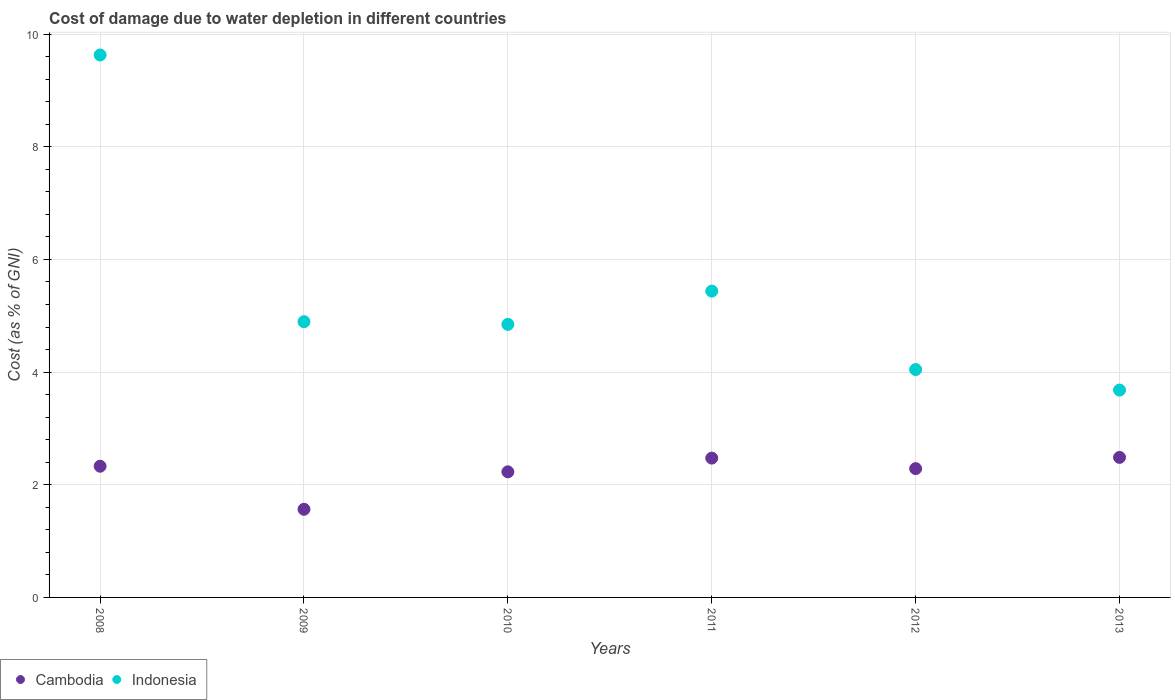What is the cost of damage caused due to water depletion in Indonesia in 2008?
Make the answer very short. 9.63. Across all years, what is the maximum cost of damage caused due to water depletion in Cambodia?
Offer a very short reply. 2.49. Across all years, what is the minimum cost of damage caused due to water depletion in Indonesia?
Provide a succinct answer. 3.68. In which year was the cost of damage caused due to water depletion in Indonesia minimum?
Provide a short and direct response. 2013. What is the total cost of damage caused due to water depletion in Cambodia in the graph?
Provide a succinct answer. 13.37. What is the difference between the cost of damage caused due to water depletion in Cambodia in 2011 and that in 2013?
Provide a short and direct response. -0.01. What is the difference between the cost of damage caused due to water depletion in Indonesia in 2010 and the cost of damage caused due to water depletion in Cambodia in 2009?
Keep it short and to the point. 3.28. What is the average cost of damage caused due to water depletion in Cambodia per year?
Your response must be concise. 2.23. In the year 2008, what is the difference between the cost of damage caused due to water depletion in Cambodia and cost of damage caused due to water depletion in Indonesia?
Your response must be concise. -7.3. What is the ratio of the cost of damage caused due to water depletion in Cambodia in 2010 to that in 2012?
Ensure brevity in your answer.  0.98. What is the difference between the highest and the second highest cost of damage caused due to water depletion in Cambodia?
Provide a succinct answer. 0.01. What is the difference between the highest and the lowest cost of damage caused due to water depletion in Cambodia?
Provide a short and direct response. 0.92. Is the sum of the cost of damage caused due to water depletion in Cambodia in 2008 and 2009 greater than the maximum cost of damage caused due to water depletion in Indonesia across all years?
Your answer should be compact. No. Is the cost of damage caused due to water depletion in Indonesia strictly greater than the cost of damage caused due to water depletion in Cambodia over the years?
Give a very brief answer. Yes. Is the cost of damage caused due to water depletion in Cambodia strictly less than the cost of damage caused due to water depletion in Indonesia over the years?
Make the answer very short. Yes. What is the difference between two consecutive major ticks on the Y-axis?
Make the answer very short. 2. Does the graph contain any zero values?
Ensure brevity in your answer.  No. How many legend labels are there?
Provide a short and direct response. 2. What is the title of the graph?
Make the answer very short. Cost of damage due to water depletion in different countries. What is the label or title of the X-axis?
Offer a terse response. Years. What is the label or title of the Y-axis?
Your answer should be very brief. Cost (as % of GNI). What is the Cost (as % of GNI) in Cambodia in 2008?
Provide a succinct answer. 2.33. What is the Cost (as % of GNI) of Indonesia in 2008?
Keep it short and to the point. 9.63. What is the Cost (as % of GNI) in Cambodia in 2009?
Provide a short and direct response. 1.56. What is the Cost (as % of GNI) in Indonesia in 2009?
Keep it short and to the point. 4.9. What is the Cost (as % of GNI) in Cambodia in 2010?
Your answer should be compact. 2.23. What is the Cost (as % of GNI) of Indonesia in 2010?
Your answer should be very brief. 4.85. What is the Cost (as % of GNI) of Cambodia in 2011?
Ensure brevity in your answer.  2.47. What is the Cost (as % of GNI) in Indonesia in 2011?
Keep it short and to the point. 5.44. What is the Cost (as % of GNI) of Cambodia in 2012?
Provide a short and direct response. 2.29. What is the Cost (as % of GNI) in Indonesia in 2012?
Make the answer very short. 4.05. What is the Cost (as % of GNI) in Cambodia in 2013?
Your answer should be compact. 2.49. What is the Cost (as % of GNI) in Indonesia in 2013?
Provide a short and direct response. 3.68. Across all years, what is the maximum Cost (as % of GNI) in Cambodia?
Your answer should be compact. 2.49. Across all years, what is the maximum Cost (as % of GNI) in Indonesia?
Offer a very short reply. 9.63. Across all years, what is the minimum Cost (as % of GNI) in Cambodia?
Keep it short and to the point. 1.56. Across all years, what is the minimum Cost (as % of GNI) of Indonesia?
Make the answer very short. 3.68. What is the total Cost (as % of GNI) in Cambodia in the graph?
Provide a succinct answer. 13.37. What is the total Cost (as % of GNI) in Indonesia in the graph?
Keep it short and to the point. 32.54. What is the difference between the Cost (as % of GNI) in Cambodia in 2008 and that in 2009?
Provide a succinct answer. 0.76. What is the difference between the Cost (as % of GNI) of Indonesia in 2008 and that in 2009?
Make the answer very short. 4.73. What is the difference between the Cost (as % of GNI) in Cambodia in 2008 and that in 2010?
Your answer should be compact. 0.1. What is the difference between the Cost (as % of GNI) of Indonesia in 2008 and that in 2010?
Provide a short and direct response. 4.78. What is the difference between the Cost (as % of GNI) of Cambodia in 2008 and that in 2011?
Keep it short and to the point. -0.14. What is the difference between the Cost (as % of GNI) of Indonesia in 2008 and that in 2011?
Ensure brevity in your answer.  4.19. What is the difference between the Cost (as % of GNI) of Cambodia in 2008 and that in 2012?
Ensure brevity in your answer.  0.04. What is the difference between the Cost (as % of GNI) in Indonesia in 2008 and that in 2012?
Provide a short and direct response. 5.58. What is the difference between the Cost (as % of GNI) of Cambodia in 2008 and that in 2013?
Offer a terse response. -0.16. What is the difference between the Cost (as % of GNI) in Indonesia in 2008 and that in 2013?
Make the answer very short. 5.95. What is the difference between the Cost (as % of GNI) in Cambodia in 2009 and that in 2010?
Give a very brief answer. -0.66. What is the difference between the Cost (as % of GNI) of Indonesia in 2009 and that in 2010?
Make the answer very short. 0.05. What is the difference between the Cost (as % of GNI) of Cambodia in 2009 and that in 2011?
Your answer should be very brief. -0.91. What is the difference between the Cost (as % of GNI) of Indonesia in 2009 and that in 2011?
Offer a terse response. -0.54. What is the difference between the Cost (as % of GNI) in Cambodia in 2009 and that in 2012?
Your answer should be compact. -0.72. What is the difference between the Cost (as % of GNI) in Indonesia in 2009 and that in 2012?
Make the answer very short. 0.85. What is the difference between the Cost (as % of GNI) in Cambodia in 2009 and that in 2013?
Give a very brief answer. -0.92. What is the difference between the Cost (as % of GNI) of Indonesia in 2009 and that in 2013?
Keep it short and to the point. 1.21. What is the difference between the Cost (as % of GNI) of Cambodia in 2010 and that in 2011?
Provide a succinct answer. -0.24. What is the difference between the Cost (as % of GNI) of Indonesia in 2010 and that in 2011?
Ensure brevity in your answer.  -0.59. What is the difference between the Cost (as % of GNI) of Cambodia in 2010 and that in 2012?
Keep it short and to the point. -0.06. What is the difference between the Cost (as % of GNI) in Indonesia in 2010 and that in 2012?
Offer a very short reply. 0.8. What is the difference between the Cost (as % of GNI) of Cambodia in 2010 and that in 2013?
Provide a succinct answer. -0.26. What is the difference between the Cost (as % of GNI) of Indonesia in 2010 and that in 2013?
Give a very brief answer. 1.17. What is the difference between the Cost (as % of GNI) of Cambodia in 2011 and that in 2012?
Offer a very short reply. 0.19. What is the difference between the Cost (as % of GNI) in Indonesia in 2011 and that in 2012?
Give a very brief answer. 1.39. What is the difference between the Cost (as % of GNI) of Cambodia in 2011 and that in 2013?
Provide a short and direct response. -0.01. What is the difference between the Cost (as % of GNI) in Indonesia in 2011 and that in 2013?
Your response must be concise. 1.76. What is the difference between the Cost (as % of GNI) in Cambodia in 2012 and that in 2013?
Provide a short and direct response. -0.2. What is the difference between the Cost (as % of GNI) of Indonesia in 2012 and that in 2013?
Give a very brief answer. 0.36. What is the difference between the Cost (as % of GNI) of Cambodia in 2008 and the Cost (as % of GNI) of Indonesia in 2009?
Ensure brevity in your answer.  -2.57. What is the difference between the Cost (as % of GNI) of Cambodia in 2008 and the Cost (as % of GNI) of Indonesia in 2010?
Your answer should be very brief. -2.52. What is the difference between the Cost (as % of GNI) of Cambodia in 2008 and the Cost (as % of GNI) of Indonesia in 2011?
Your answer should be compact. -3.11. What is the difference between the Cost (as % of GNI) of Cambodia in 2008 and the Cost (as % of GNI) of Indonesia in 2012?
Offer a terse response. -1.72. What is the difference between the Cost (as % of GNI) in Cambodia in 2008 and the Cost (as % of GNI) in Indonesia in 2013?
Offer a terse response. -1.35. What is the difference between the Cost (as % of GNI) of Cambodia in 2009 and the Cost (as % of GNI) of Indonesia in 2010?
Your answer should be very brief. -3.28. What is the difference between the Cost (as % of GNI) of Cambodia in 2009 and the Cost (as % of GNI) of Indonesia in 2011?
Keep it short and to the point. -3.87. What is the difference between the Cost (as % of GNI) of Cambodia in 2009 and the Cost (as % of GNI) of Indonesia in 2012?
Keep it short and to the point. -2.48. What is the difference between the Cost (as % of GNI) of Cambodia in 2009 and the Cost (as % of GNI) of Indonesia in 2013?
Give a very brief answer. -2.12. What is the difference between the Cost (as % of GNI) of Cambodia in 2010 and the Cost (as % of GNI) of Indonesia in 2011?
Ensure brevity in your answer.  -3.21. What is the difference between the Cost (as % of GNI) of Cambodia in 2010 and the Cost (as % of GNI) of Indonesia in 2012?
Offer a very short reply. -1.82. What is the difference between the Cost (as % of GNI) in Cambodia in 2010 and the Cost (as % of GNI) in Indonesia in 2013?
Provide a succinct answer. -1.45. What is the difference between the Cost (as % of GNI) of Cambodia in 2011 and the Cost (as % of GNI) of Indonesia in 2012?
Provide a succinct answer. -1.57. What is the difference between the Cost (as % of GNI) of Cambodia in 2011 and the Cost (as % of GNI) of Indonesia in 2013?
Provide a short and direct response. -1.21. What is the difference between the Cost (as % of GNI) of Cambodia in 2012 and the Cost (as % of GNI) of Indonesia in 2013?
Keep it short and to the point. -1.39. What is the average Cost (as % of GNI) in Cambodia per year?
Your answer should be very brief. 2.23. What is the average Cost (as % of GNI) of Indonesia per year?
Offer a very short reply. 5.42. In the year 2008, what is the difference between the Cost (as % of GNI) of Cambodia and Cost (as % of GNI) of Indonesia?
Give a very brief answer. -7.3. In the year 2009, what is the difference between the Cost (as % of GNI) of Cambodia and Cost (as % of GNI) of Indonesia?
Give a very brief answer. -3.33. In the year 2010, what is the difference between the Cost (as % of GNI) of Cambodia and Cost (as % of GNI) of Indonesia?
Offer a very short reply. -2.62. In the year 2011, what is the difference between the Cost (as % of GNI) of Cambodia and Cost (as % of GNI) of Indonesia?
Ensure brevity in your answer.  -2.96. In the year 2012, what is the difference between the Cost (as % of GNI) of Cambodia and Cost (as % of GNI) of Indonesia?
Offer a very short reply. -1.76. In the year 2013, what is the difference between the Cost (as % of GNI) of Cambodia and Cost (as % of GNI) of Indonesia?
Provide a short and direct response. -1.19. What is the ratio of the Cost (as % of GNI) of Cambodia in 2008 to that in 2009?
Offer a very short reply. 1.49. What is the ratio of the Cost (as % of GNI) in Indonesia in 2008 to that in 2009?
Keep it short and to the point. 1.97. What is the ratio of the Cost (as % of GNI) in Cambodia in 2008 to that in 2010?
Give a very brief answer. 1.04. What is the ratio of the Cost (as % of GNI) in Indonesia in 2008 to that in 2010?
Offer a very short reply. 1.99. What is the ratio of the Cost (as % of GNI) of Cambodia in 2008 to that in 2011?
Give a very brief answer. 0.94. What is the ratio of the Cost (as % of GNI) in Indonesia in 2008 to that in 2011?
Offer a terse response. 1.77. What is the ratio of the Cost (as % of GNI) in Cambodia in 2008 to that in 2012?
Ensure brevity in your answer.  1.02. What is the ratio of the Cost (as % of GNI) of Indonesia in 2008 to that in 2012?
Offer a terse response. 2.38. What is the ratio of the Cost (as % of GNI) in Cambodia in 2008 to that in 2013?
Offer a very short reply. 0.94. What is the ratio of the Cost (as % of GNI) of Indonesia in 2008 to that in 2013?
Give a very brief answer. 2.62. What is the ratio of the Cost (as % of GNI) of Cambodia in 2009 to that in 2010?
Offer a very short reply. 0.7. What is the ratio of the Cost (as % of GNI) of Indonesia in 2009 to that in 2010?
Provide a short and direct response. 1.01. What is the ratio of the Cost (as % of GNI) in Cambodia in 2009 to that in 2011?
Provide a succinct answer. 0.63. What is the ratio of the Cost (as % of GNI) of Indonesia in 2009 to that in 2011?
Ensure brevity in your answer.  0.9. What is the ratio of the Cost (as % of GNI) of Cambodia in 2009 to that in 2012?
Provide a short and direct response. 0.68. What is the ratio of the Cost (as % of GNI) of Indonesia in 2009 to that in 2012?
Your response must be concise. 1.21. What is the ratio of the Cost (as % of GNI) of Cambodia in 2009 to that in 2013?
Keep it short and to the point. 0.63. What is the ratio of the Cost (as % of GNI) of Indonesia in 2009 to that in 2013?
Your answer should be very brief. 1.33. What is the ratio of the Cost (as % of GNI) of Cambodia in 2010 to that in 2011?
Keep it short and to the point. 0.9. What is the ratio of the Cost (as % of GNI) in Indonesia in 2010 to that in 2011?
Make the answer very short. 0.89. What is the ratio of the Cost (as % of GNI) in Cambodia in 2010 to that in 2012?
Offer a very short reply. 0.98. What is the ratio of the Cost (as % of GNI) in Indonesia in 2010 to that in 2012?
Offer a very short reply. 1.2. What is the ratio of the Cost (as % of GNI) of Cambodia in 2010 to that in 2013?
Offer a very short reply. 0.9. What is the ratio of the Cost (as % of GNI) of Indonesia in 2010 to that in 2013?
Your answer should be compact. 1.32. What is the ratio of the Cost (as % of GNI) of Cambodia in 2011 to that in 2012?
Provide a short and direct response. 1.08. What is the ratio of the Cost (as % of GNI) in Indonesia in 2011 to that in 2012?
Give a very brief answer. 1.34. What is the ratio of the Cost (as % of GNI) in Cambodia in 2011 to that in 2013?
Keep it short and to the point. 0.99. What is the ratio of the Cost (as % of GNI) in Indonesia in 2011 to that in 2013?
Ensure brevity in your answer.  1.48. What is the ratio of the Cost (as % of GNI) in Cambodia in 2012 to that in 2013?
Offer a very short reply. 0.92. What is the ratio of the Cost (as % of GNI) in Indonesia in 2012 to that in 2013?
Make the answer very short. 1.1. What is the difference between the highest and the second highest Cost (as % of GNI) of Cambodia?
Provide a succinct answer. 0.01. What is the difference between the highest and the second highest Cost (as % of GNI) of Indonesia?
Offer a terse response. 4.19. What is the difference between the highest and the lowest Cost (as % of GNI) in Cambodia?
Your answer should be compact. 0.92. What is the difference between the highest and the lowest Cost (as % of GNI) of Indonesia?
Keep it short and to the point. 5.95. 